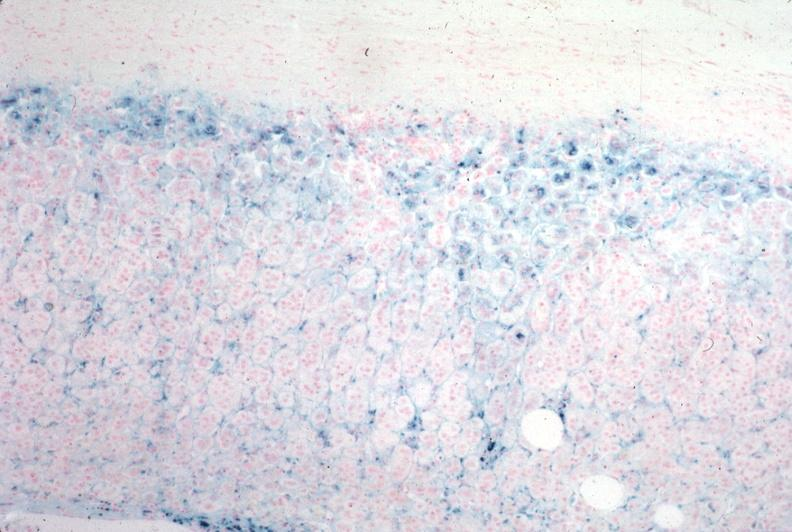does natural color show iron stain?
Answer the question using a single word or phrase. No 